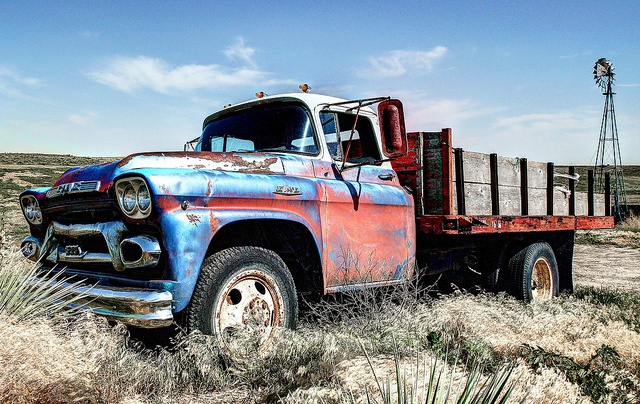Describe the objects in this image and their specific colors. I can see a truck in gray, black, lightgray, and darkgray tones in this image. 